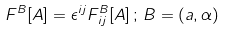Convert formula to latex. <formula><loc_0><loc_0><loc_500><loc_500>F ^ { B } [ A ] = \epsilon ^ { i j } F ^ { B } _ { \, i j } [ A ] \, ; \, B = \left ( a , \alpha \right )</formula> 